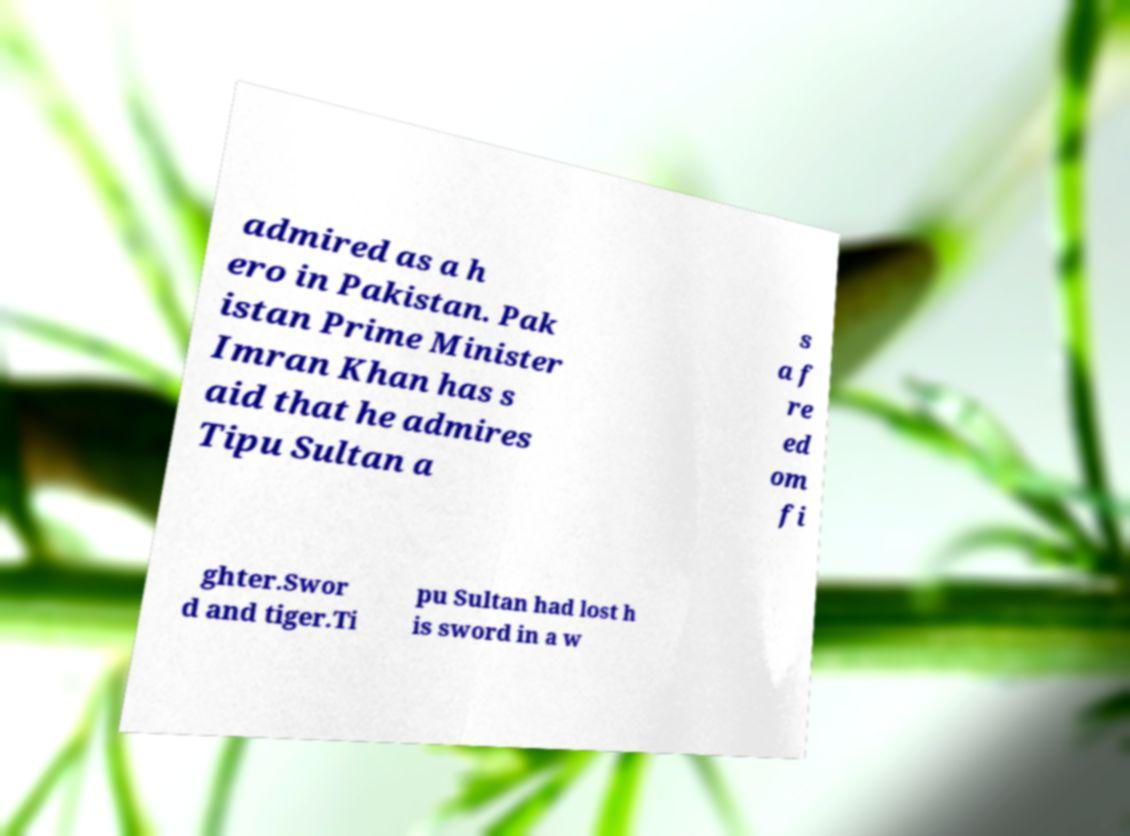For documentation purposes, I need the text within this image transcribed. Could you provide that? admired as a h ero in Pakistan. Pak istan Prime Minister Imran Khan has s aid that he admires Tipu Sultan a s a f re ed om fi ghter.Swor d and tiger.Ti pu Sultan had lost h is sword in a w 